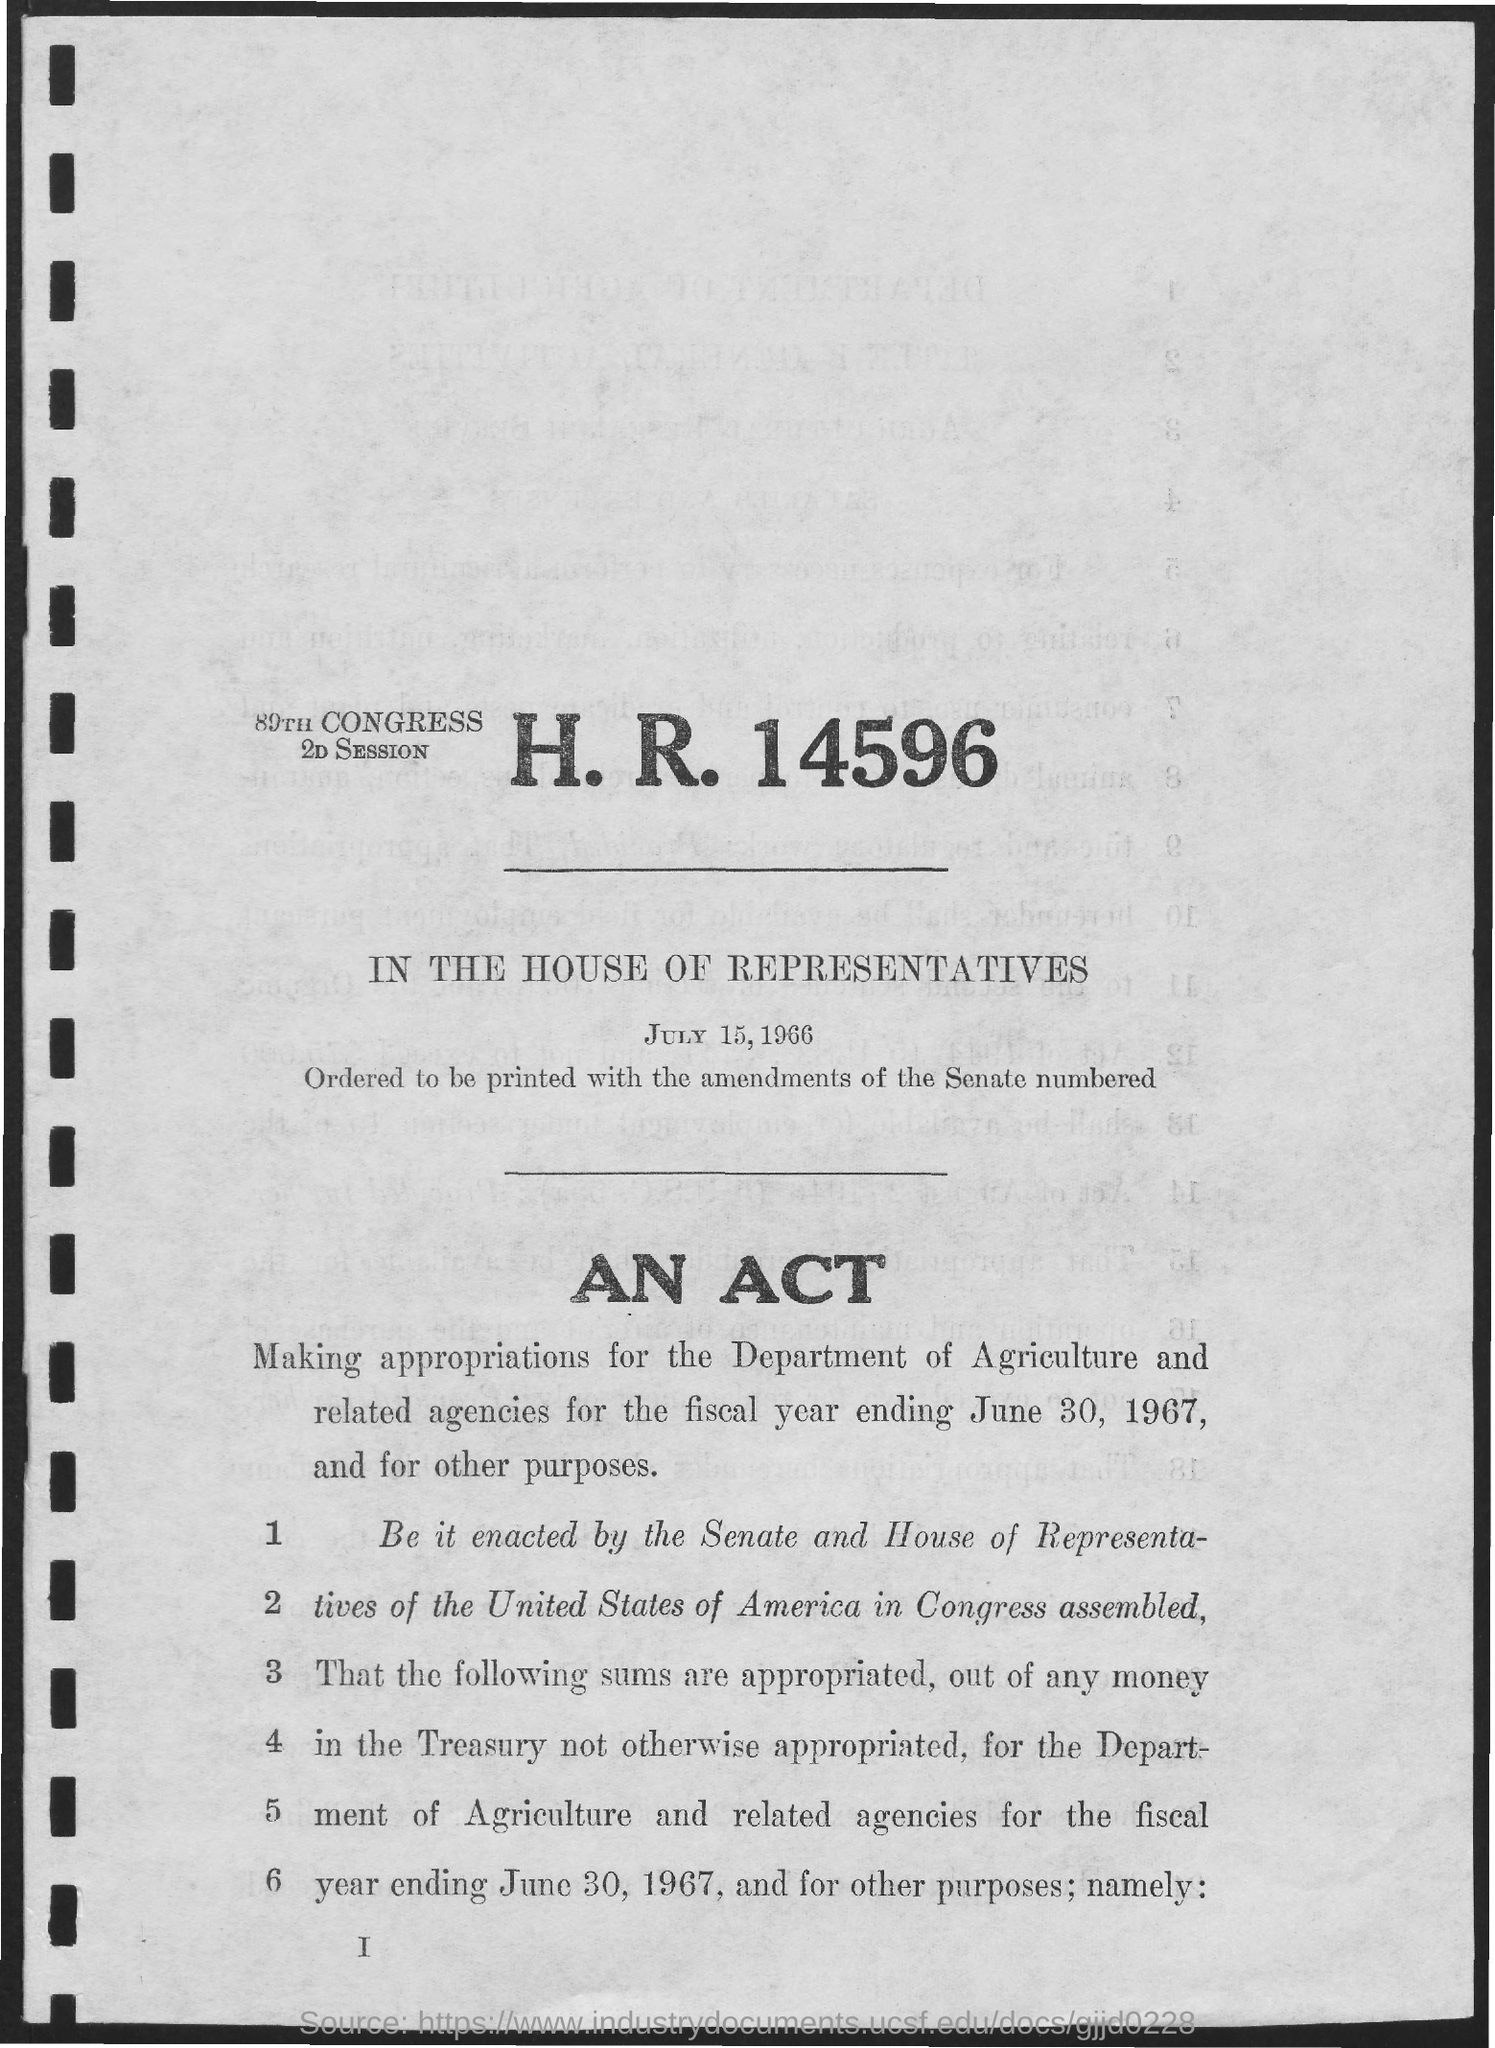Who all assembled in congress?
Keep it short and to the point. The senate and house of representatives of the united states of america. 